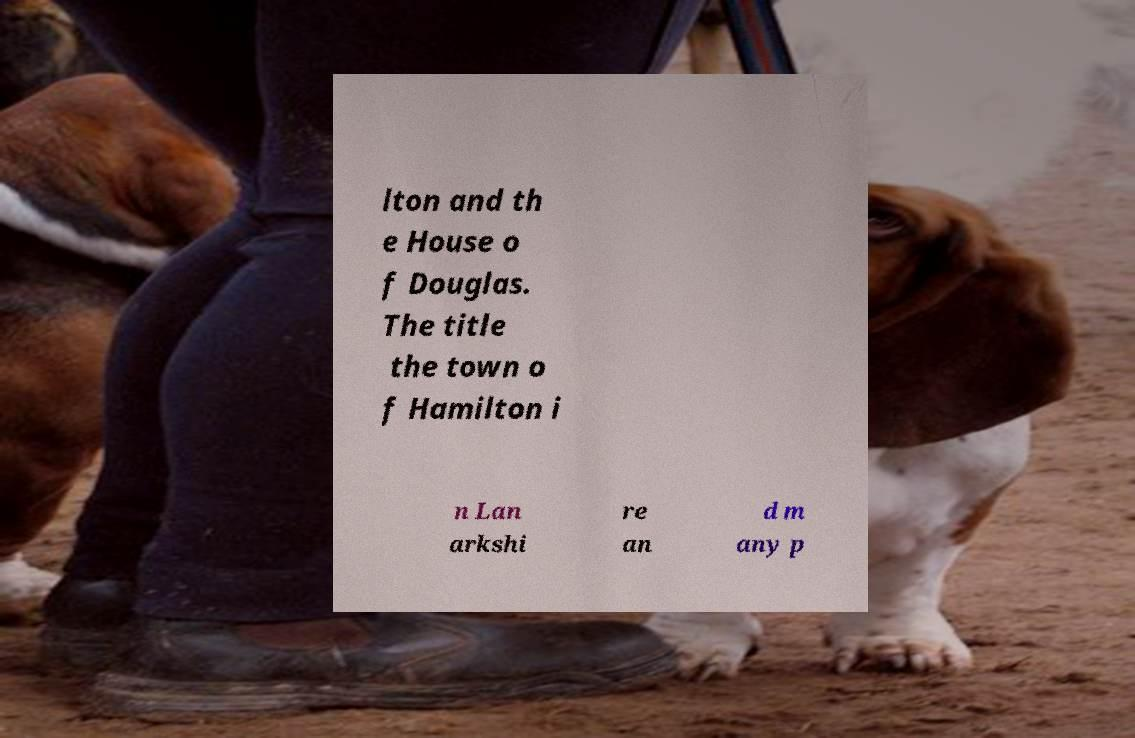Please read and relay the text visible in this image. What does it say? lton and th e House o f Douglas. The title the town o f Hamilton i n Lan arkshi re an d m any p 